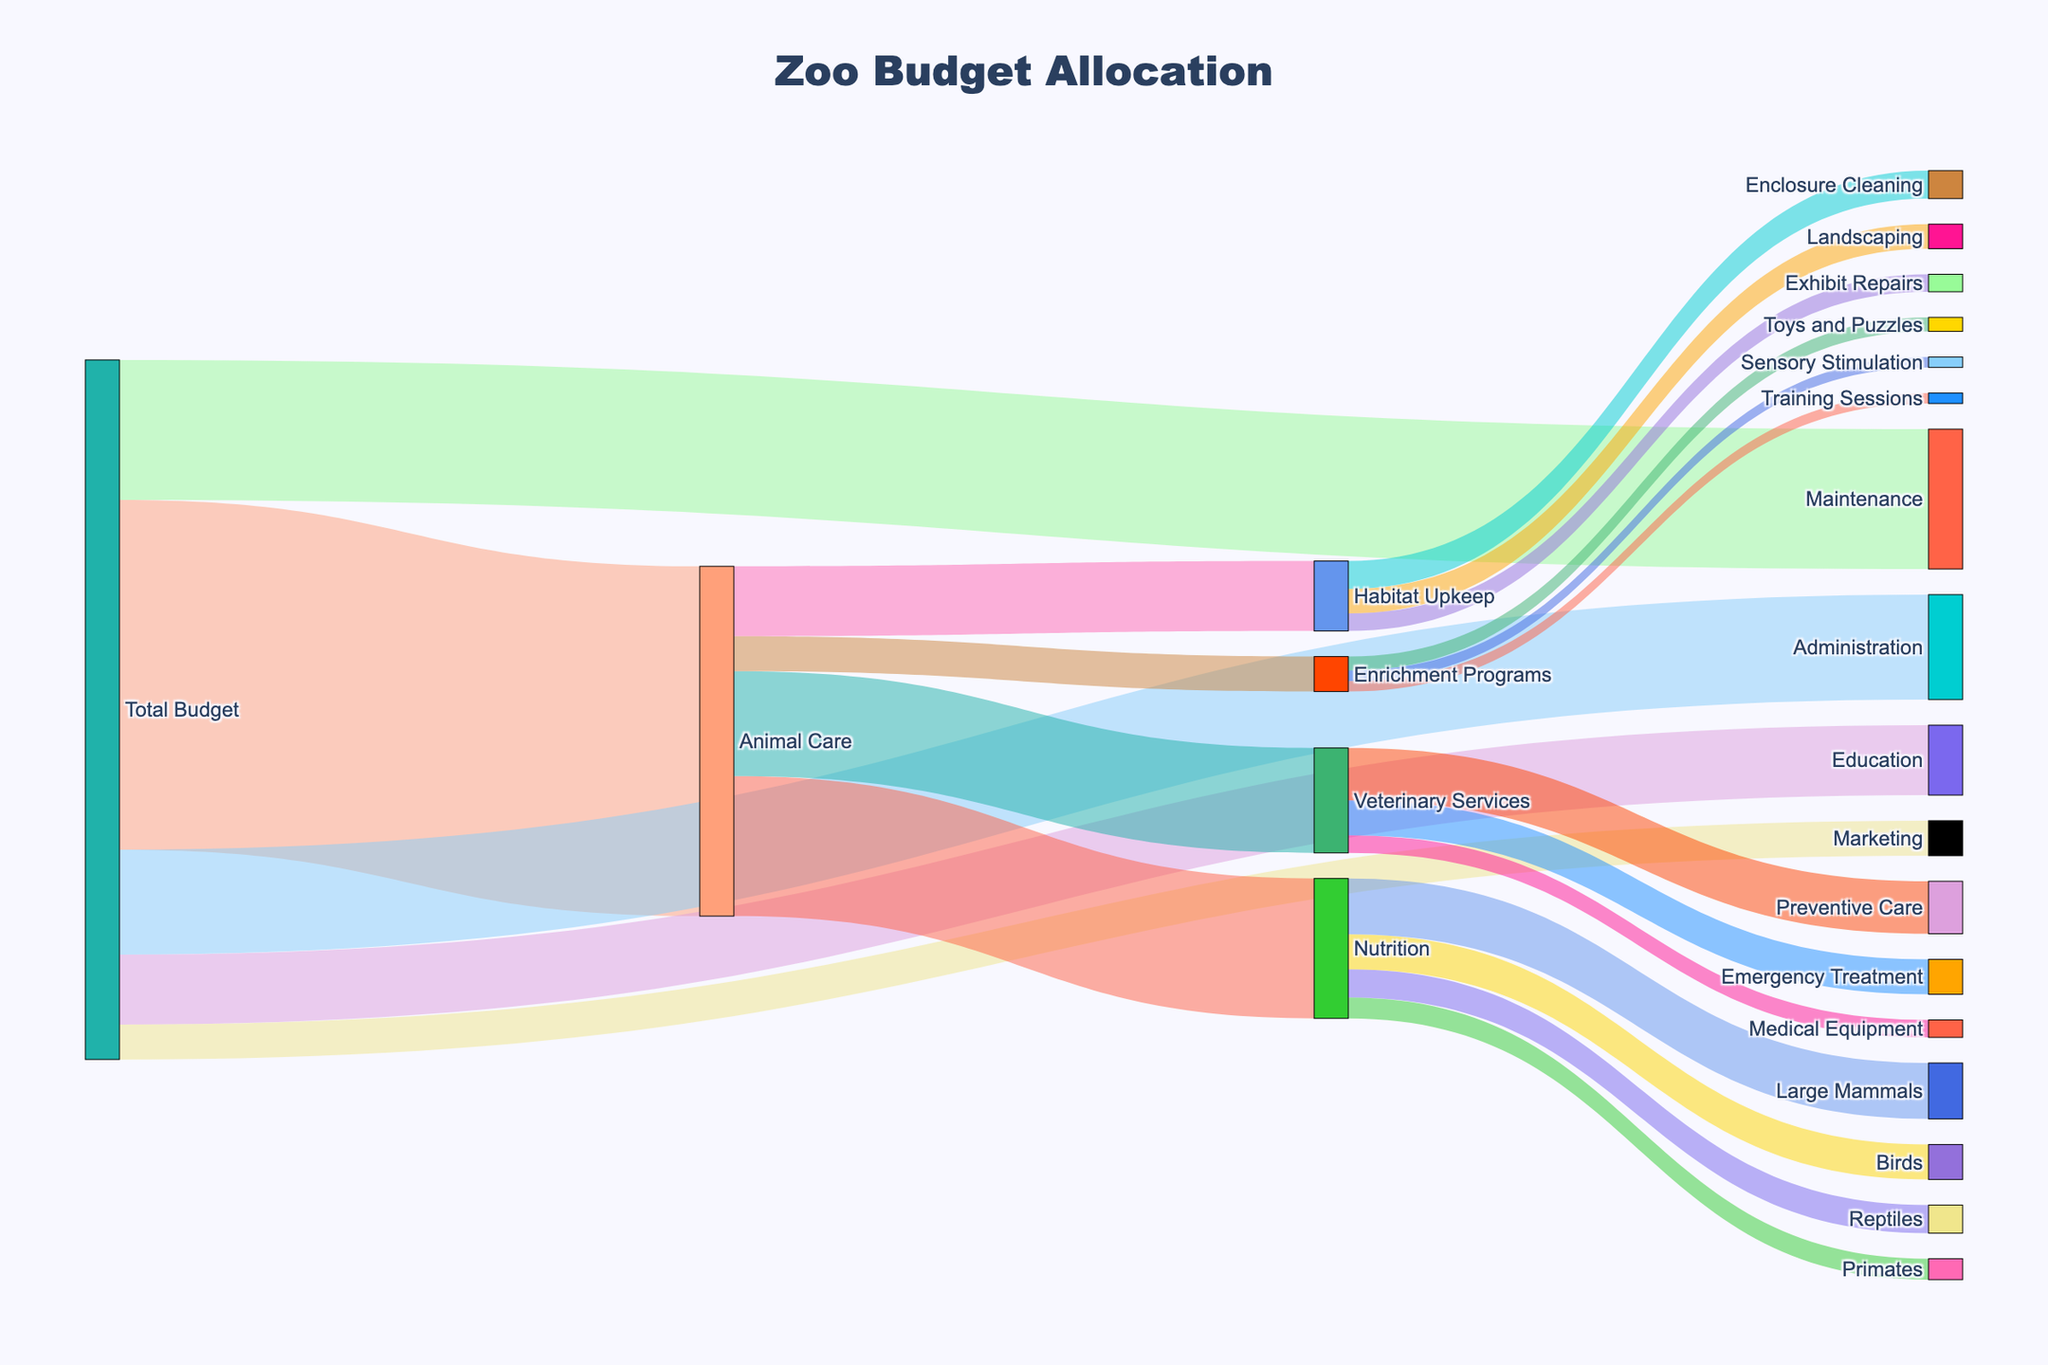how is the total budget distributed among the main departments? The total budget is divided into five main departments: Animal Care, Maintenance, Administration, Education, and Marketing. By looking at the width of the links, we see that Animal Care gets 500,000, Maintenance gets 200,000, Administration gets 150,000, Education gets 100,000, and Marketing gets 50,000.
Answer: Animal Care: 500,000, Maintenance: 200,000, Administration: 150,000, Education: 100,000, Marketing: 50,000 How much is allocated to Veterinary Services within Animal Care? By looking at the links extending from Animal Care, we can see that Veterinary Services has a value of 150,000.
Answer: 150,000 Which specific area within Nutrition receives the highest budget? Within the Nutrition section, the animals receiving the budgets are Large Mammals, Birds, Reptiles, and Primates. The width of the link shows that Large Mammals receive 80,000, the highest amount.
Answer: Large Mammals: 80,000 What is the combined budget for Enclosure Cleaning and Exhibit Repairs within Habitat Upkeep? To find the combined budget, add the values for Enclosure Cleaning (40,000) and Exhibit Repairs (25,000). 40,000 + 25,000 = 65,000.
Answer: 65,000 Which department receives the smallest allocation from the total budget? By looking at the links coming from the Total Budget, we can see the values allocated to each department. The smallest value is 50,000, which goes to Marketing.
Answer: Marketing: 50,000 How does the budget for Sensory Stimulation within Enrichment Programs compare to the budget for Training Sessions? Both Sensory Stimulation and Training Sessions receive budgets within the Enrichment Programs. Sensory Stimulation receives 15,000 and Training Sessions also receives 15,000, making them equal.
Answer: Equal: 15,000 each What is the total budget allocated for Animal Care and Maintenance combined? To find the combined budget for Animal Care and Maintenance, add their values: 500,000 (Animal Care) + 200,000 (Maintenance) = 700,000.
Answer: 700,000 How does the budget for Emergency Treatment within Veterinary Services compare to Preventive Care? Within Veterinary Services, the budget for Emergency Treatment is 50,000, while Preventive Care is allocated 75,000. Preventive Care receives more.
Answer: Preventive Care: 75,000 > Emergency Treatment: 50,000 Which specific category within Enrichment Programs receives the largest funding? The three categories under Enrichment Programs are Toys and Puzzles, Training Sessions, and Sensory Stimulation. The link shows that Toys and Puzzles receive the largest amount, which is 20,000.
Answer: Toys and Puzzles: 20,000 